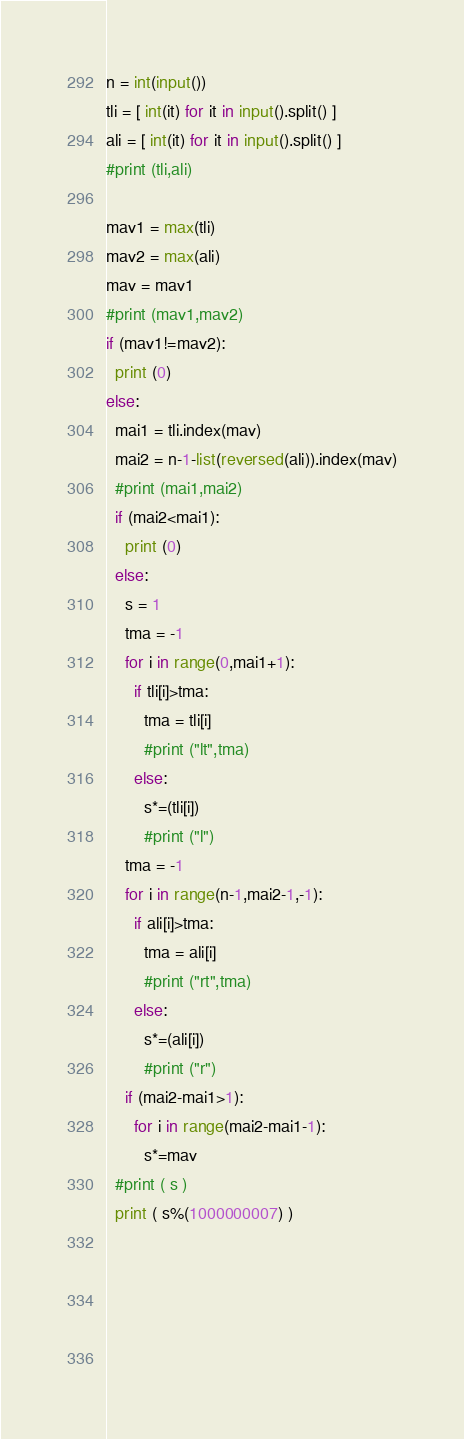Convert code to text. <code><loc_0><loc_0><loc_500><loc_500><_Python_>n = int(input())
tli = [ int(it) for it in input().split() ]
ali = [ int(it) for it in input().split() ]
#print (tli,ali)

mav1 = max(tli)
mav2 = max(ali)
mav = mav1
#print (mav1,mav2)
if (mav1!=mav2):
  print (0)
else:
  mai1 = tli.index(mav)
  mai2 = n-1-list(reversed(ali)).index(mav)
  #print (mai1,mai2)
  if (mai2<mai1):
    print (0)
  else:
    s = 1
    tma = -1
    for i in range(0,mai1+1):
      if tli[i]>tma:
        tma = tli[i]
        #print ("lt",tma)
      else:
        s*=(tli[i])
        #print ("l")
    tma = -1
    for i in range(n-1,mai2-1,-1):
      if ali[i]>tma:
        tma = ali[i]
        #print ("rt",tma)
      else:
        s*=(ali[i])
        #print ("r")
    if (mai2-mai1>1):
      for i in range(mai2-mai1-1):
        s*=mav
  #print ( s )
  print ( s%(1000000007) )
      
    
        
    
 </code> 